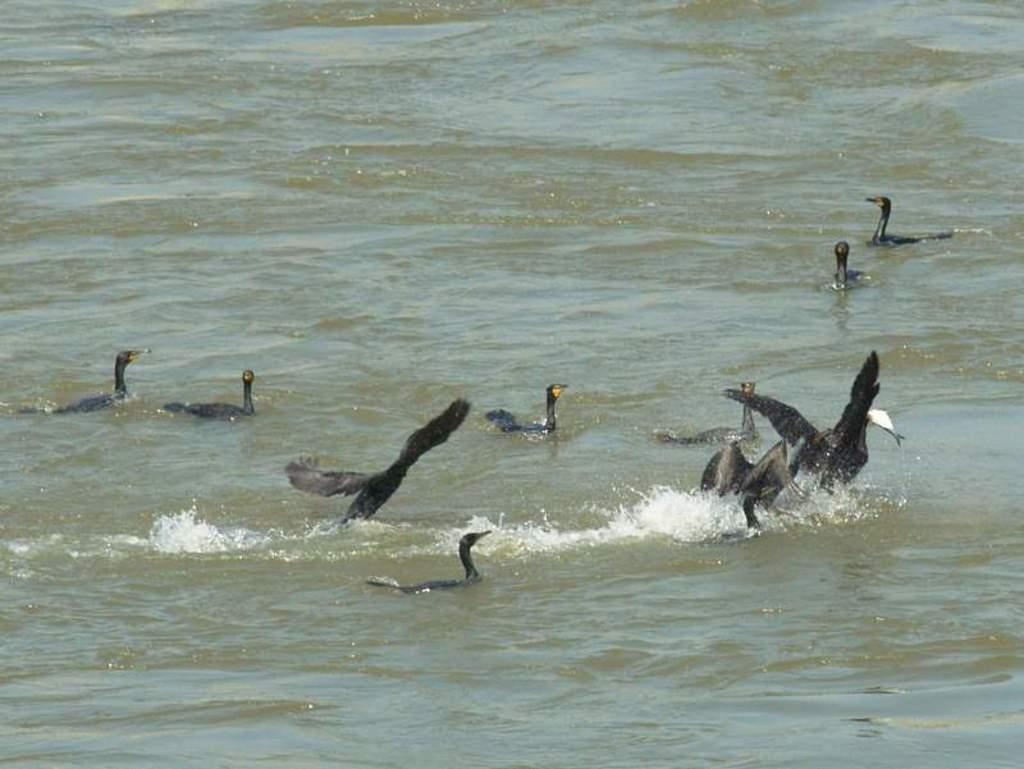What type of animals can be seen in the image? Birds can be seen in the image. Where are the birds located in the image? The birds are on the surface of the water. What color are the eyes of the cloth in the image? There is no cloth present in the image, and therefore no eyes to describe. 